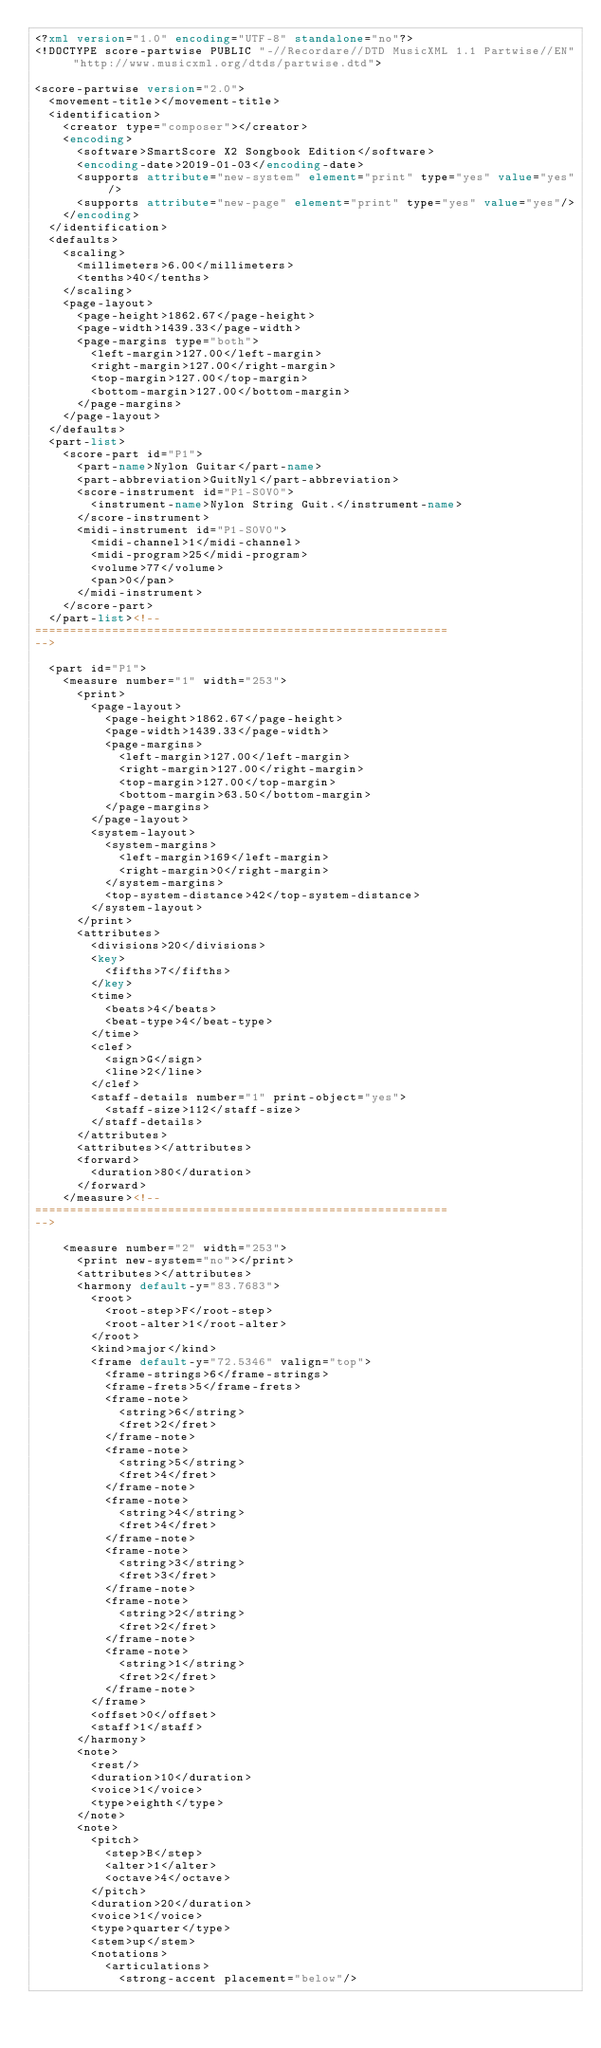<code> <loc_0><loc_0><loc_500><loc_500><_XML_><?xml version="1.0" encoding="UTF-8" standalone="no"?>
<!DOCTYPE score-partwise PUBLIC "-//Recordare//DTD MusicXML 1.1 Partwise//EN" "http://www.musicxml.org/dtds/partwise.dtd">

<score-partwise version="2.0">
	<movement-title></movement-title>
	<identification>
		<creator type="composer"></creator>
		<encoding>
			<software>SmartScore X2 Songbook Edition</software>
			<encoding-date>2019-01-03</encoding-date>
			<supports attribute="new-system" element="print" type="yes" value="yes"/>
			<supports attribute="new-page" element="print" type="yes" value="yes"/>
		</encoding>
	</identification>
	<defaults>
		<scaling>
			<millimeters>6.00</millimeters>
			<tenths>40</tenths>
		</scaling>
		<page-layout>
			<page-height>1862.67</page-height>
			<page-width>1439.33</page-width>
			<page-margins type="both">
				<left-margin>127.00</left-margin>
				<right-margin>127.00</right-margin>
				<top-margin>127.00</top-margin>
				<bottom-margin>127.00</bottom-margin>
			</page-margins>
		</page-layout>
	</defaults>
	<part-list>
		<score-part id="P1">
			<part-name>Nylon Guitar</part-name>
			<part-abbreviation>GuitNyl</part-abbreviation>
			<score-instrument id="P1-S0V0">
				<instrument-name>Nylon String Guit.</instrument-name>
			</score-instrument>
			<midi-instrument id="P1-S0V0">
				<midi-channel>1</midi-channel>
				<midi-program>25</midi-program>
				<volume>77</volume>
				<pan>0</pan>
			</midi-instrument>
		</score-part>
	</part-list><!--
===========================================================
-->

	<part id="P1">
		<measure number="1" width="253">
			<print>
				<page-layout>
					<page-height>1862.67</page-height>
					<page-width>1439.33</page-width>
					<page-margins>
						<left-margin>127.00</left-margin>
						<right-margin>127.00</right-margin>
						<top-margin>127.00</top-margin>
						<bottom-margin>63.50</bottom-margin>
					</page-margins>
				</page-layout>
				<system-layout>
					<system-margins>
						<left-margin>169</left-margin>
						<right-margin>0</right-margin>
					</system-margins>
					<top-system-distance>42</top-system-distance>
				</system-layout>
			</print>
			<attributes>
				<divisions>20</divisions>
				<key>
					<fifths>7</fifths>
				</key>
				<time>
					<beats>4</beats>
					<beat-type>4</beat-type>
				</time>
				<clef>
					<sign>G</sign>
					<line>2</line>
				</clef>
				<staff-details number="1" print-object="yes">
					<staff-size>112</staff-size>
				</staff-details>
			</attributes>
			<attributes></attributes>
			<forward>
				<duration>80</duration>
			</forward>
		</measure><!--
===========================================================
-->

		<measure number="2" width="253">
			<print new-system="no"></print>
			<attributes></attributes>
			<harmony default-y="83.7683">
				<root>
					<root-step>F</root-step>
					<root-alter>1</root-alter>
				</root>
				<kind>major</kind>
				<frame default-y="72.5346" valign="top">
					<frame-strings>6</frame-strings>
					<frame-frets>5</frame-frets>
					<frame-note>
						<string>6</string>
						<fret>2</fret>
					</frame-note>
					<frame-note>
						<string>5</string>
						<fret>4</fret>
					</frame-note>
					<frame-note>
						<string>4</string>
						<fret>4</fret>
					</frame-note>
					<frame-note>
						<string>3</string>
						<fret>3</fret>
					</frame-note>
					<frame-note>
						<string>2</string>
						<fret>2</fret>
					</frame-note>
					<frame-note>
						<string>1</string>
						<fret>2</fret>
					</frame-note>
				</frame>
				<offset>0</offset>
				<staff>1</staff>
			</harmony>
			<note>
				<rest/>
				<duration>10</duration>
				<voice>1</voice>
				<type>eighth</type>
			</note>
			<note>
				<pitch>
					<step>B</step>
					<alter>1</alter>
					<octave>4</octave>
				</pitch>
				<duration>20</duration>
				<voice>1</voice>
				<type>quarter</type>
				<stem>up</stem>
				<notations>
					<articulations>
						<strong-accent placement="below"/></code> 